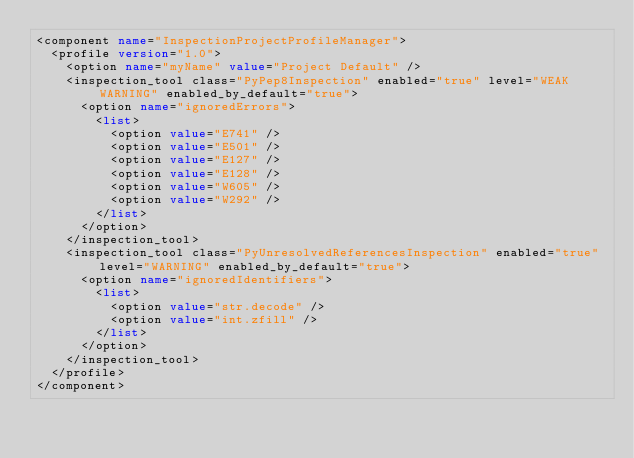Convert code to text. <code><loc_0><loc_0><loc_500><loc_500><_XML_><component name="InspectionProjectProfileManager">
  <profile version="1.0">
    <option name="myName" value="Project Default" />
    <inspection_tool class="PyPep8Inspection" enabled="true" level="WEAK WARNING" enabled_by_default="true">
      <option name="ignoredErrors">
        <list>
          <option value="E741" />
          <option value="E501" />
          <option value="E127" />
          <option value="E128" />
          <option value="W605" />
          <option value="W292" />
        </list>
      </option>
    </inspection_tool>
    <inspection_tool class="PyUnresolvedReferencesInspection" enabled="true" level="WARNING" enabled_by_default="true">
      <option name="ignoredIdentifiers">
        <list>
          <option value="str.decode" />
          <option value="int.zfill" />
        </list>
      </option>
    </inspection_tool>
  </profile>
</component></code> 